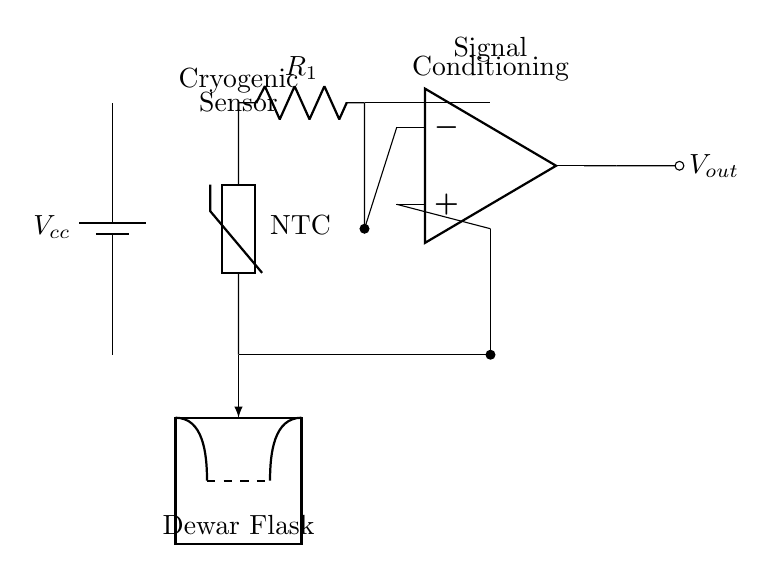What type of temperature sensor is used in this circuit? The circuit uses an NTC thermistor, which is indicated in the circuit diagram near the temperature sensor label. NTC means that its resistance decreases as temperature increases.
Answer: NTC thermistor What is the purpose of the operational amplifier in this circuit? The operational amplifier is used for signal conditioning. It amplifies the low-level signal from the voltage divider formed by the thermistor and the resistor, increasing the output signal to a usable level.
Answer: Signal conditioning What are the two main components forming the voltage divider in this circuit? The voltage divider is formed by the thermistor and the resistor labeled R1. The connection between these components creates a voltage that varies with temperature changes detected by the thermistor.
Answer: Thermistor and R1 What is the output voltage of the circuit labeled as? The output voltage is labeled as Vout in the circuit diagram, indicating the output signal after processing by the operational amplifier.
Answer: Vout What does the dashed line represent in the circuit diagram? The dashed line indicates the level where the cryogenic fluid is monitored inside the Dewar flask, symbolizing the interface between the sensor and the fluid level.
Answer: Fluid level interface How does temperature affect the output signal of the circuit? As temperature increases, the NTC thermistor’s resistance decreases, which changes the voltage divider output, thereby affecting the input to the operational amplifier and resulting in a corresponding change in Vout.
Answer: Voltage changes with temperature 